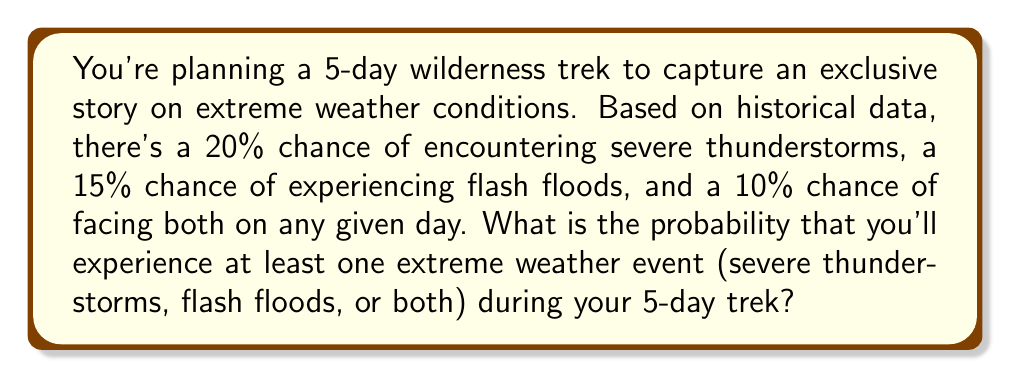Solve this math problem. Let's approach this step-by-step:

1) First, let's calculate the probability of experiencing no extreme weather on a single day:

   P(no extreme weather) = 1 - P(thunderstorms or floods or both)
   
   Using the addition rule of probability:
   P(thunderstorms or floods or both) = P(thunderstorms) + P(floods) - P(both)
   = 0.20 + 0.15 - 0.10 = 0.25

   So, P(no extreme weather) = 1 - 0.25 = 0.75 or 75%

2) For the entire 5-day trek, we need the probability of having no extreme weather for all 5 days:

   P(no extreme weather for 5 days) = $(0.75)^5$ = 0.2373 or about 23.73%

3) Therefore, the probability of experiencing at least one extreme weather event is the complement of this:

   P(at least one extreme weather event) = 1 - P(no extreme weather for 5 days)
   = 1 - 0.2373 = 0.7627 or about 76.27%
Answer: $76.27\%$ 